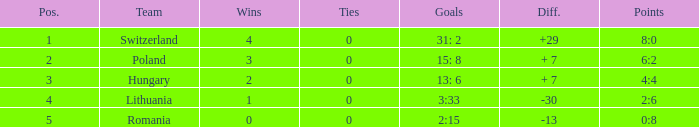What is the most wins when the number of losses was less than 4 and there was more than 0 ties? None. 